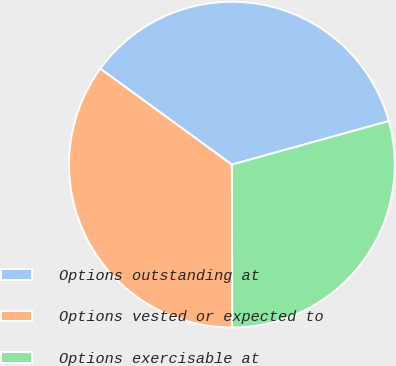Convert chart to OTSL. <chart><loc_0><loc_0><loc_500><loc_500><pie_chart><fcel>Options outstanding at<fcel>Options vested or expected to<fcel>Options exercisable at<nl><fcel>35.67%<fcel>35.06%<fcel>29.27%<nl></chart> 